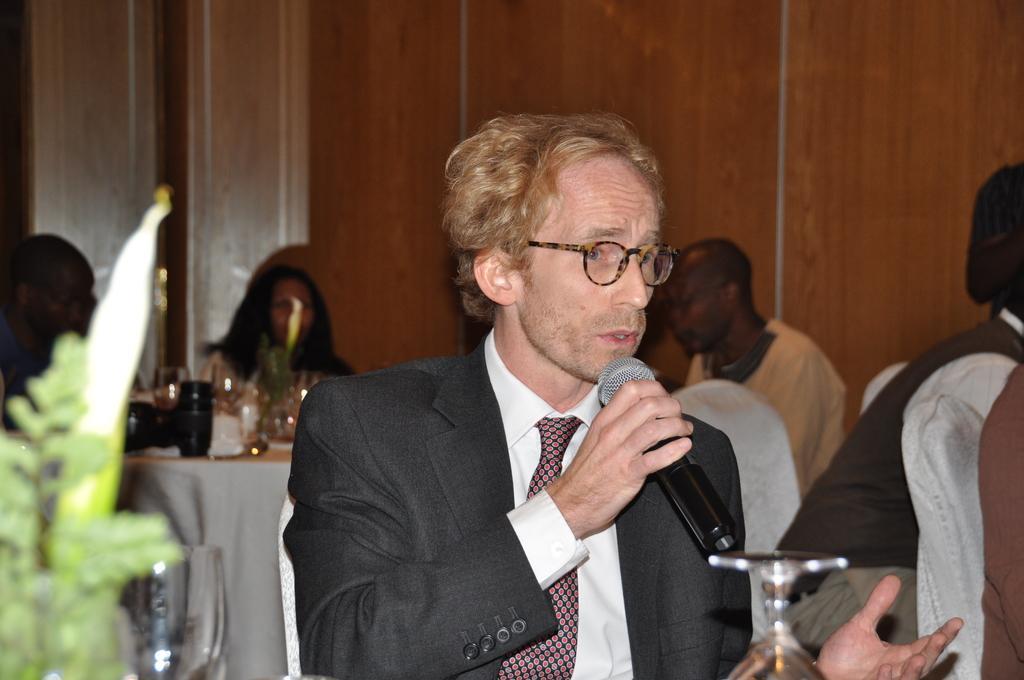Can you describe this image briefly? In this image, we can see a man sitting and holding a microphone, there are some people sitting on the chairs, we can see a table and there is a wall. 